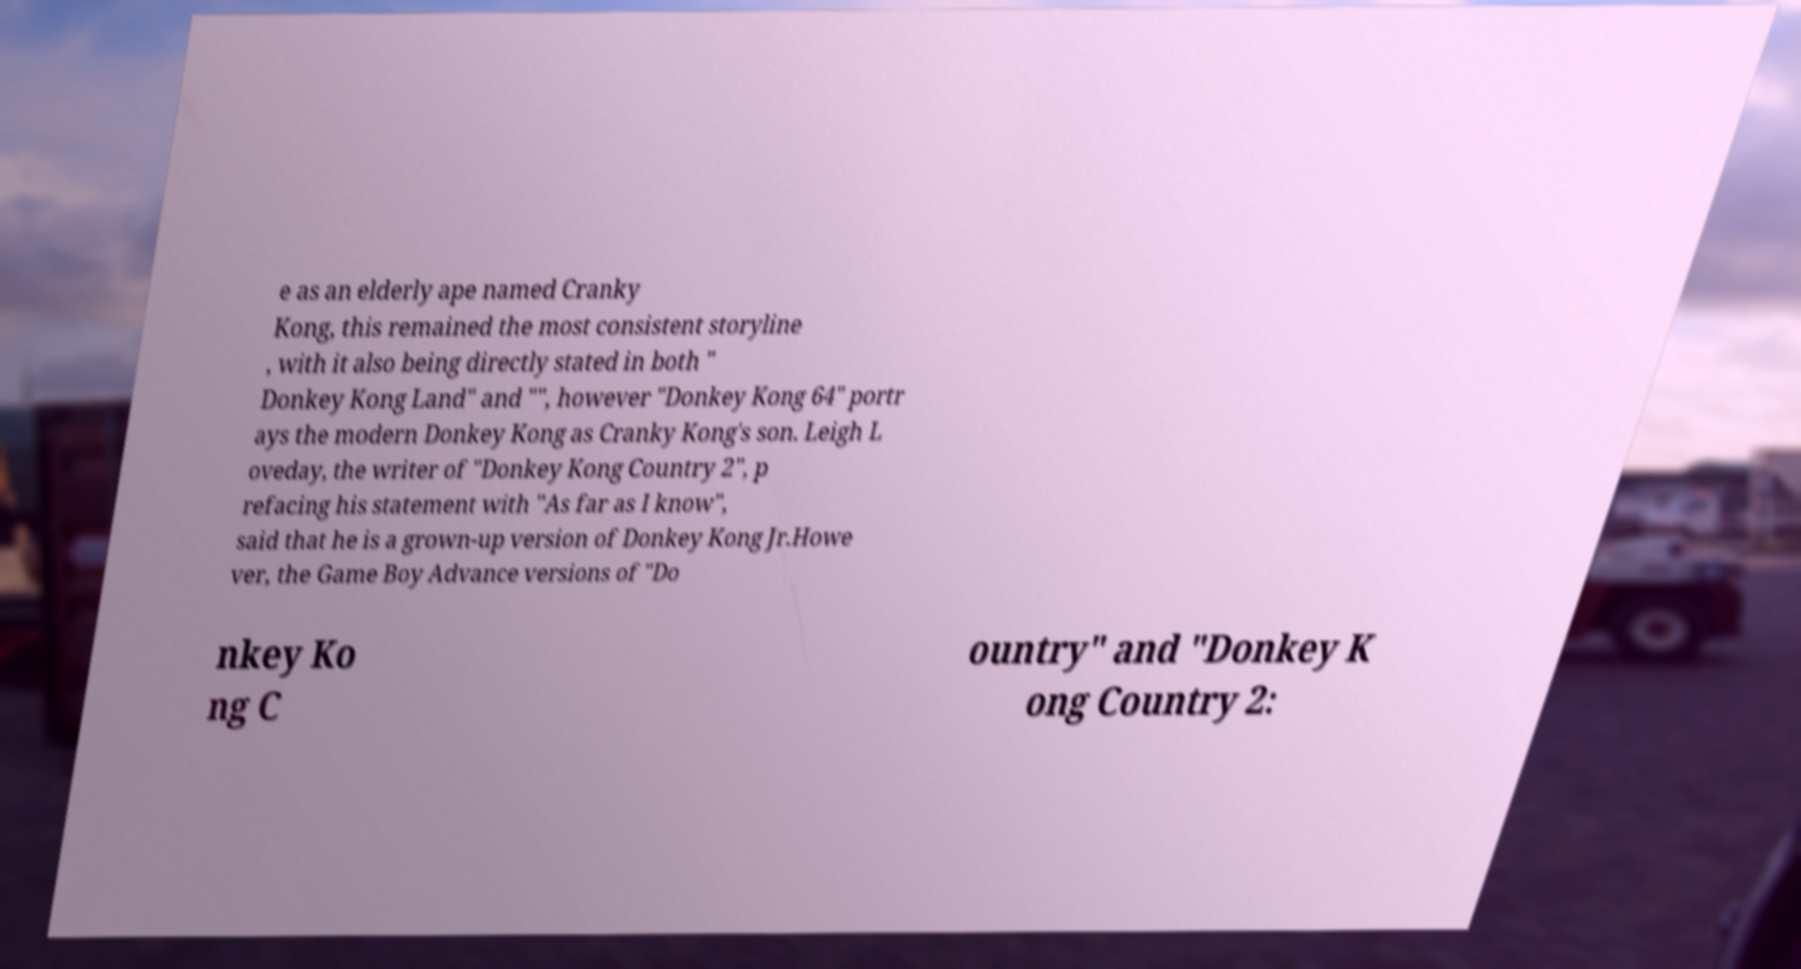What messages or text are displayed in this image? I need them in a readable, typed format. e as an elderly ape named Cranky Kong, this remained the most consistent storyline , with it also being directly stated in both " Donkey Kong Land" and "", however "Donkey Kong 64" portr ays the modern Donkey Kong as Cranky Kong's son. Leigh L oveday, the writer of "Donkey Kong Country 2", p refacing his statement with "As far as I know", said that he is a grown-up version of Donkey Kong Jr.Howe ver, the Game Boy Advance versions of "Do nkey Ko ng C ountry" and "Donkey K ong Country 2: 